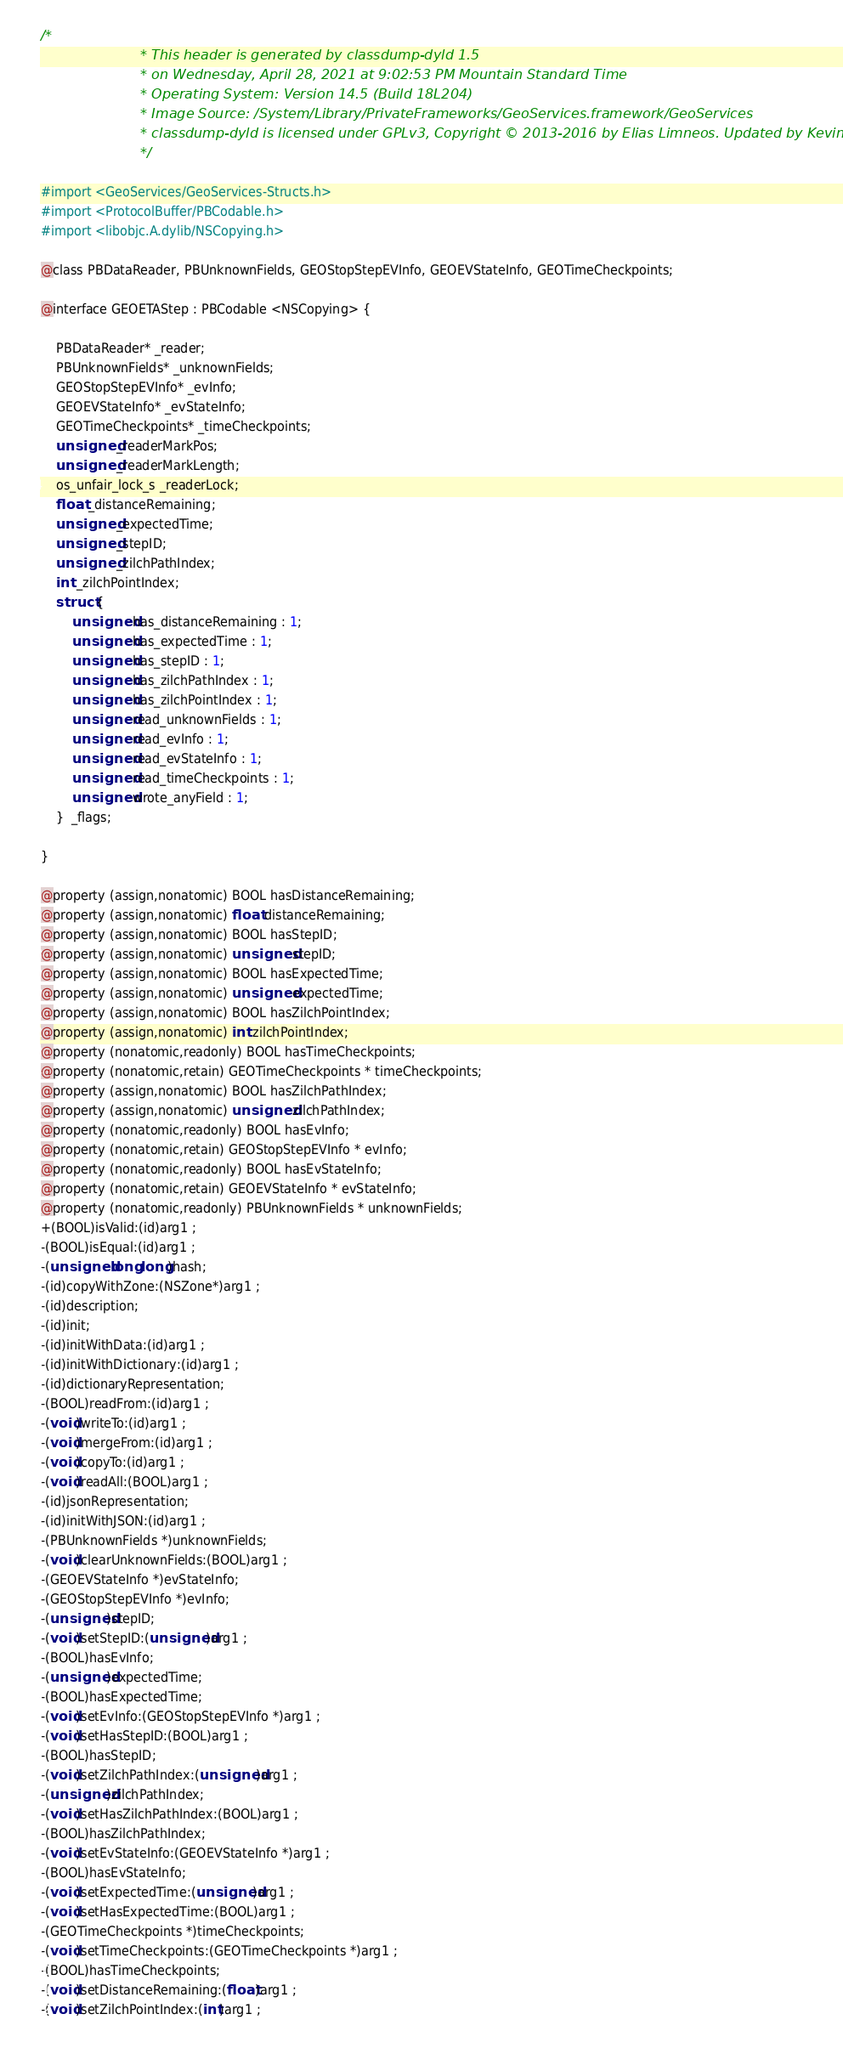<code> <loc_0><loc_0><loc_500><loc_500><_C_>/*
                       * This header is generated by classdump-dyld 1.5
                       * on Wednesday, April 28, 2021 at 9:02:53 PM Mountain Standard Time
                       * Operating System: Version 14.5 (Build 18L204)
                       * Image Source: /System/Library/PrivateFrameworks/GeoServices.framework/GeoServices
                       * classdump-dyld is licensed under GPLv3, Copyright © 2013-2016 by Elias Limneos. Updated by Kevin Bradley.
                       */

#import <GeoServices/GeoServices-Structs.h>
#import <ProtocolBuffer/PBCodable.h>
#import <libobjc.A.dylib/NSCopying.h>

@class PBDataReader, PBUnknownFields, GEOStopStepEVInfo, GEOEVStateInfo, GEOTimeCheckpoints;

@interface GEOETAStep : PBCodable <NSCopying> {

	PBDataReader* _reader;
	PBUnknownFields* _unknownFields;
	GEOStopStepEVInfo* _evInfo;
	GEOEVStateInfo* _evStateInfo;
	GEOTimeCheckpoints* _timeCheckpoints;
	unsigned _readerMarkPos;
	unsigned _readerMarkLength;
	os_unfair_lock_s _readerLock;
	float _distanceRemaining;
	unsigned _expectedTime;
	unsigned _stepID;
	unsigned _zilchPathIndex;
	int _zilchPointIndex;
	struct {
		unsigned has_distanceRemaining : 1;
		unsigned has_expectedTime : 1;
		unsigned has_stepID : 1;
		unsigned has_zilchPathIndex : 1;
		unsigned has_zilchPointIndex : 1;
		unsigned read_unknownFields : 1;
		unsigned read_evInfo : 1;
		unsigned read_evStateInfo : 1;
		unsigned read_timeCheckpoints : 1;
		unsigned wrote_anyField : 1;
	}  _flags;

}

@property (assign,nonatomic) BOOL hasDistanceRemaining; 
@property (assign,nonatomic) float distanceRemaining; 
@property (assign,nonatomic) BOOL hasStepID; 
@property (assign,nonatomic) unsigned stepID; 
@property (assign,nonatomic) BOOL hasExpectedTime; 
@property (assign,nonatomic) unsigned expectedTime; 
@property (assign,nonatomic) BOOL hasZilchPointIndex; 
@property (assign,nonatomic) int zilchPointIndex; 
@property (nonatomic,readonly) BOOL hasTimeCheckpoints; 
@property (nonatomic,retain) GEOTimeCheckpoints * timeCheckpoints; 
@property (assign,nonatomic) BOOL hasZilchPathIndex; 
@property (assign,nonatomic) unsigned zilchPathIndex; 
@property (nonatomic,readonly) BOOL hasEvInfo; 
@property (nonatomic,retain) GEOStopStepEVInfo * evInfo; 
@property (nonatomic,readonly) BOOL hasEvStateInfo; 
@property (nonatomic,retain) GEOEVStateInfo * evStateInfo; 
@property (nonatomic,readonly) PBUnknownFields * unknownFields; 
+(BOOL)isValid:(id)arg1 ;
-(BOOL)isEqual:(id)arg1 ;
-(unsigned long long)hash;
-(id)copyWithZone:(NSZone*)arg1 ;
-(id)description;
-(id)init;
-(id)initWithData:(id)arg1 ;
-(id)initWithDictionary:(id)arg1 ;
-(id)dictionaryRepresentation;
-(BOOL)readFrom:(id)arg1 ;
-(void)writeTo:(id)arg1 ;
-(void)mergeFrom:(id)arg1 ;
-(void)copyTo:(id)arg1 ;
-(void)readAll:(BOOL)arg1 ;
-(id)jsonRepresentation;
-(id)initWithJSON:(id)arg1 ;
-(PBUnknownFields *)unknownFields;
-(void)clearUnknownFields:(BOOL)arg1 ;
-(GEOEVStateInfo *)evStateInfo;
-(GEOStopStepEVInfo *)evInfo;
-(unsigned)stepID;
-(void)setStepID:(unsigned)arg1 ;
-(BOOL)hasEvInfo;
-(unsigned)expectedTime;
-(BOOL)hasExpectedTime;
-(void)setEvInfo:(GEOStopStepEVInfo *)arg1 ;
-(void)setHasStepID:(BOOL)arg1 ;
-(BOOL)hasStepID;
-(void)setZilchPathIndex:(unsigned)arg1 ;
-(unsigned)zilchPathIndex;
-(void)setHasZilchPathIndex:(BOOL)arg1 ;
-(BOOL)hasZilchPathIndex;
-(void)setEvStateInfo:(GEOEVStateInfo *)arg1 ;
-(BOOL)hasEvStateInfo;
-(void)setExpectedTime:(unsigned)arg1 ;
-(void)setHasExpectedTime:(BOOL)arg1 ;
-(GEOTimeCheckpoints *)timeCheckpoints;
-(void)setTimeCheckpoints:(GEOTimeCheckpoints *)arg1 ;
-(BOOL)hasTimeCheckpoints;
-(void)setDistanceRemaining:(float)arg1 ;
-(void)setZilchPointIndex:(int)arg1 ;</code> 